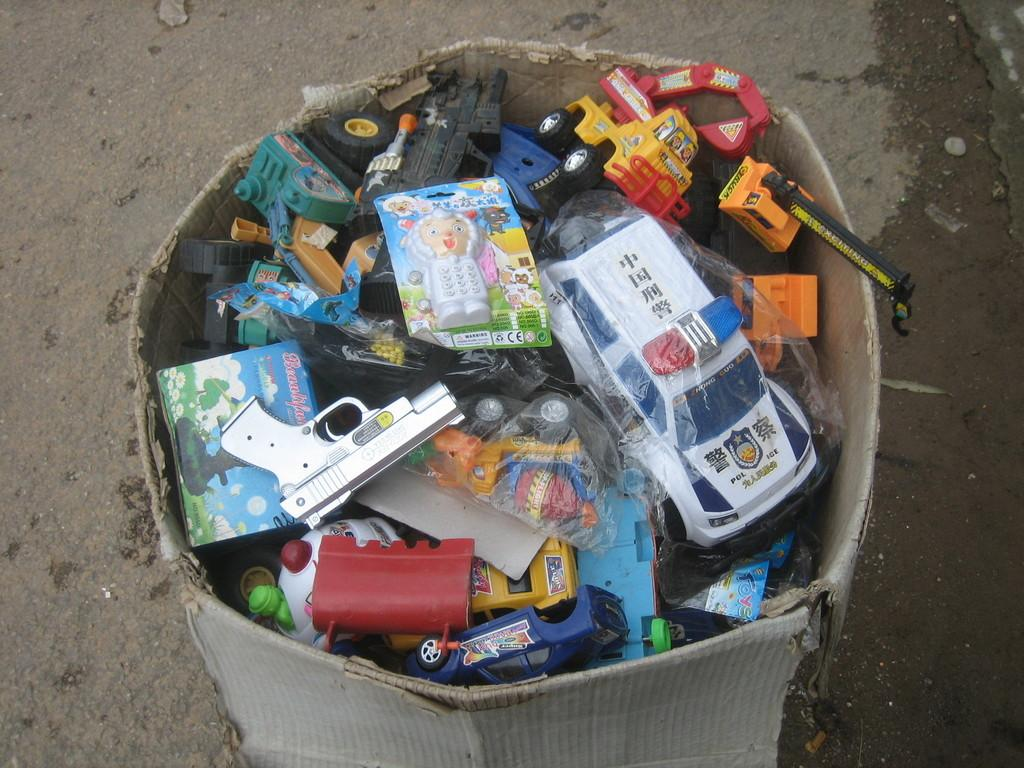What is the main object in the image? There is a carton box in the image. What is inside the carton box? The carton box contains toy gun, dolls, and toy vehicles. Where is the carton box located? The carton box is placed on the road. What type of plantation can be seen in the background of the image? There is no plantation present in the image; it only features a carton box with toys on the road. 